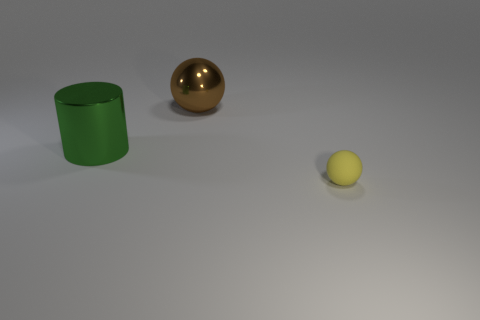Are there any other things that are the same size as the yellow ball?
Your response must be concise. No. What number of things are big cylinders or small balls?
Provide a short and direct response. 2. What number of large green metallic things are on the right side of the metallic thing on the left side of the ball behind the tiny yellow rubber thing?
Keep it short and to the point. 0. There is another object that is the same shape as the yellow rubber thing; what material is it?
Provide a short and direct response. Metal. There is a thing that is to the right of the green cylinder and in front of the metallic ball; what is it made of?
Your answer should be very brief. Rubber. Is the number of large spheres that are left of the green object less than the number of large brown metal objects right of the big brown ball?
Keep it short and to the point. No. What number of other things are the same size as the yellow rubber sphere?
Keep it short and to the point. 0. What shape is the big shiny thing that is right of the large object that is in front of the ball that is behind the small matte thing?
Make the answer very short. Sphere. How many purple things are tiny spheres or big things?
Offer a terse response. 0. What number of balls are right of the sphere that is left of the small sphere?
Offer a terse response. 1. 